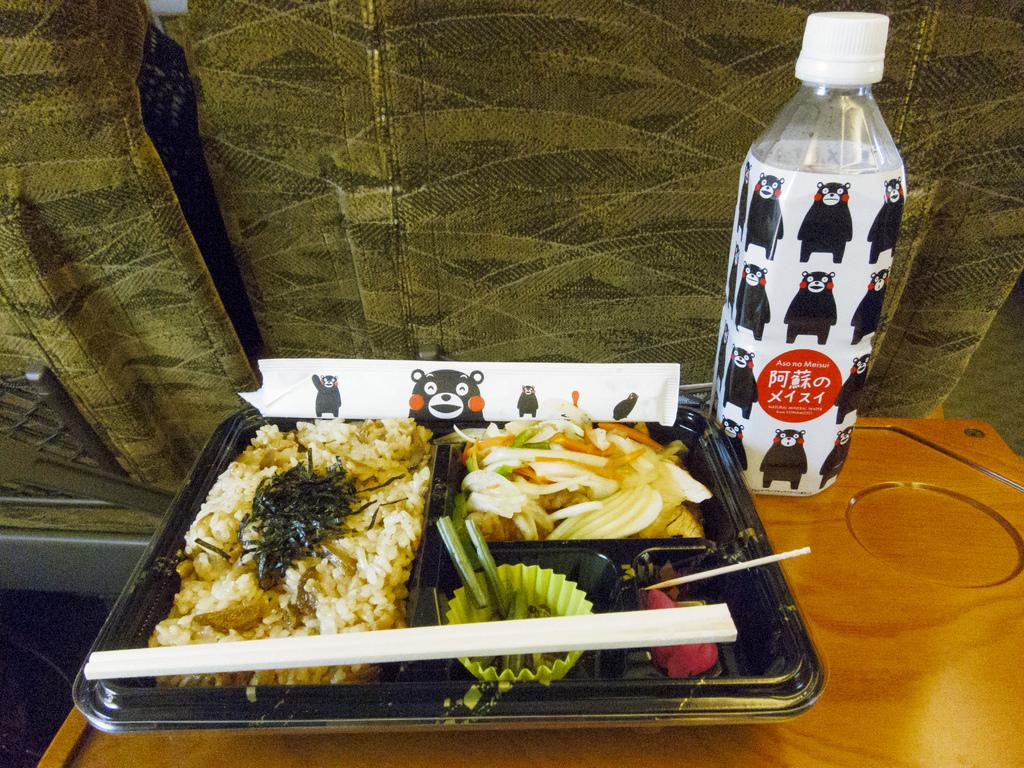<image>
Present a compact description of the photo's key features. A tray of food is on a wooden table and a bottle is next to it that says Aso no Meisui. 